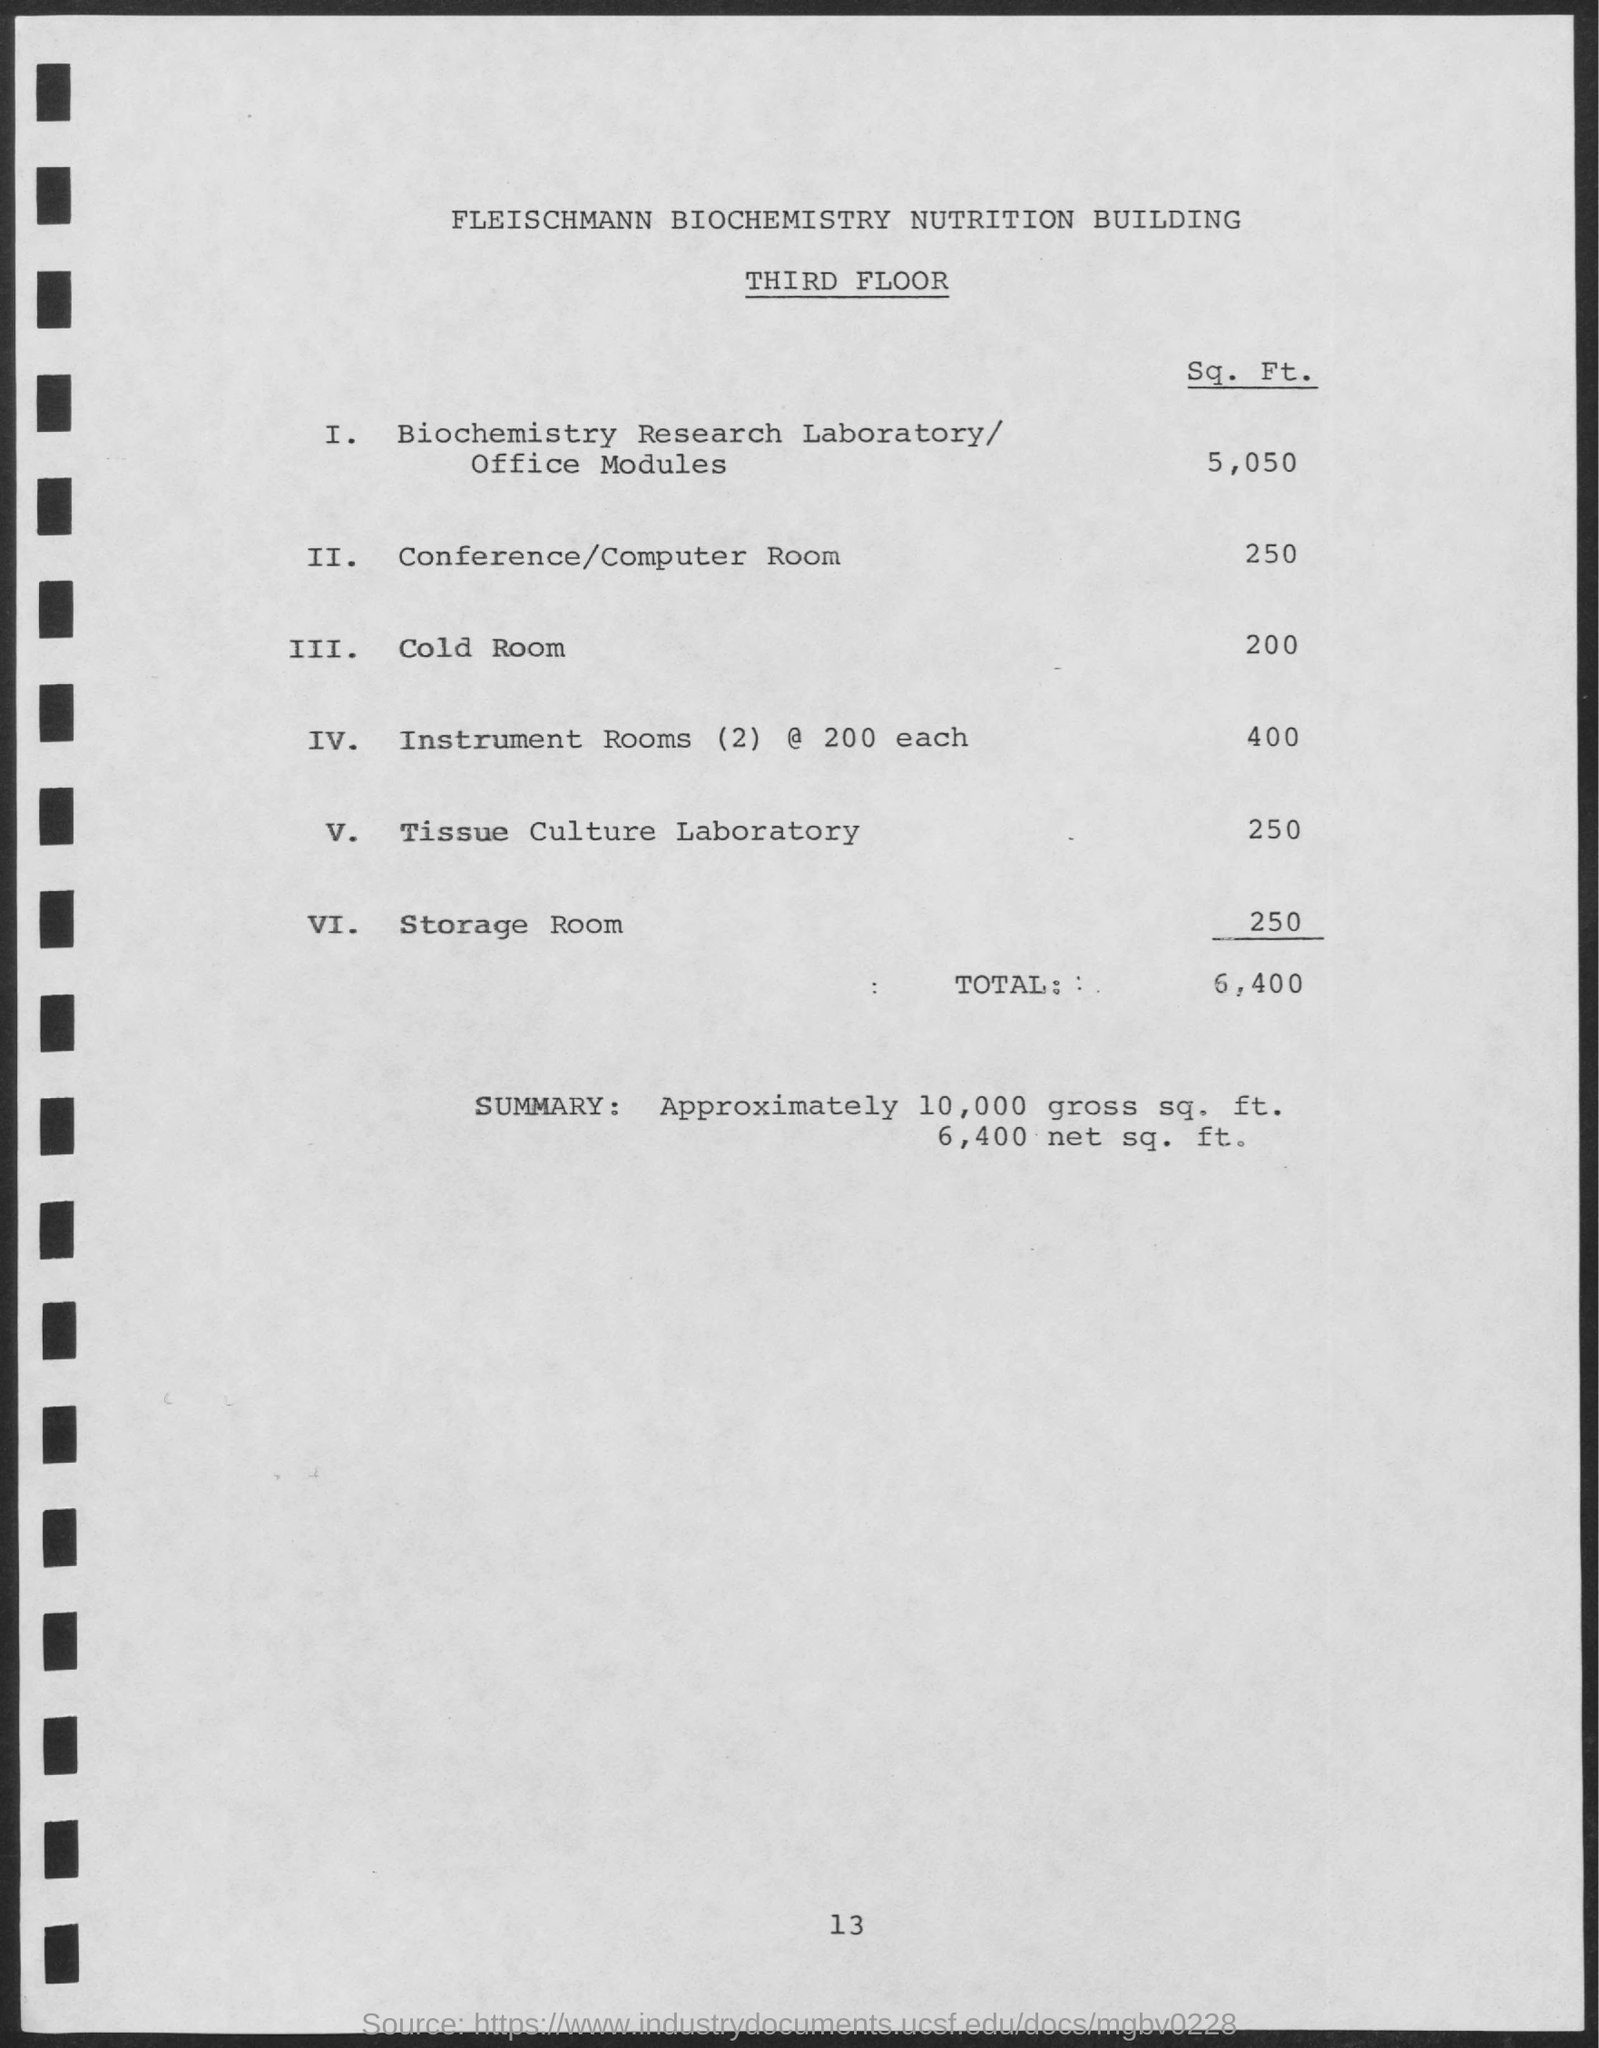What is the building name?
Ensure brevity in your answer.  Fleischmann biochemistry nutrition building. Which floor is mentioned?
Your answer should be very brief. Third. How much is the total sq. ft.?
Your answer should be compact. 6,400. How much is the sq. ft. for cold room?
Ensure brevity in your answer.  200. Approximately how much is the gross sq. ft.?
Keep it short and to the point. 10,000 gross sq. ft. 